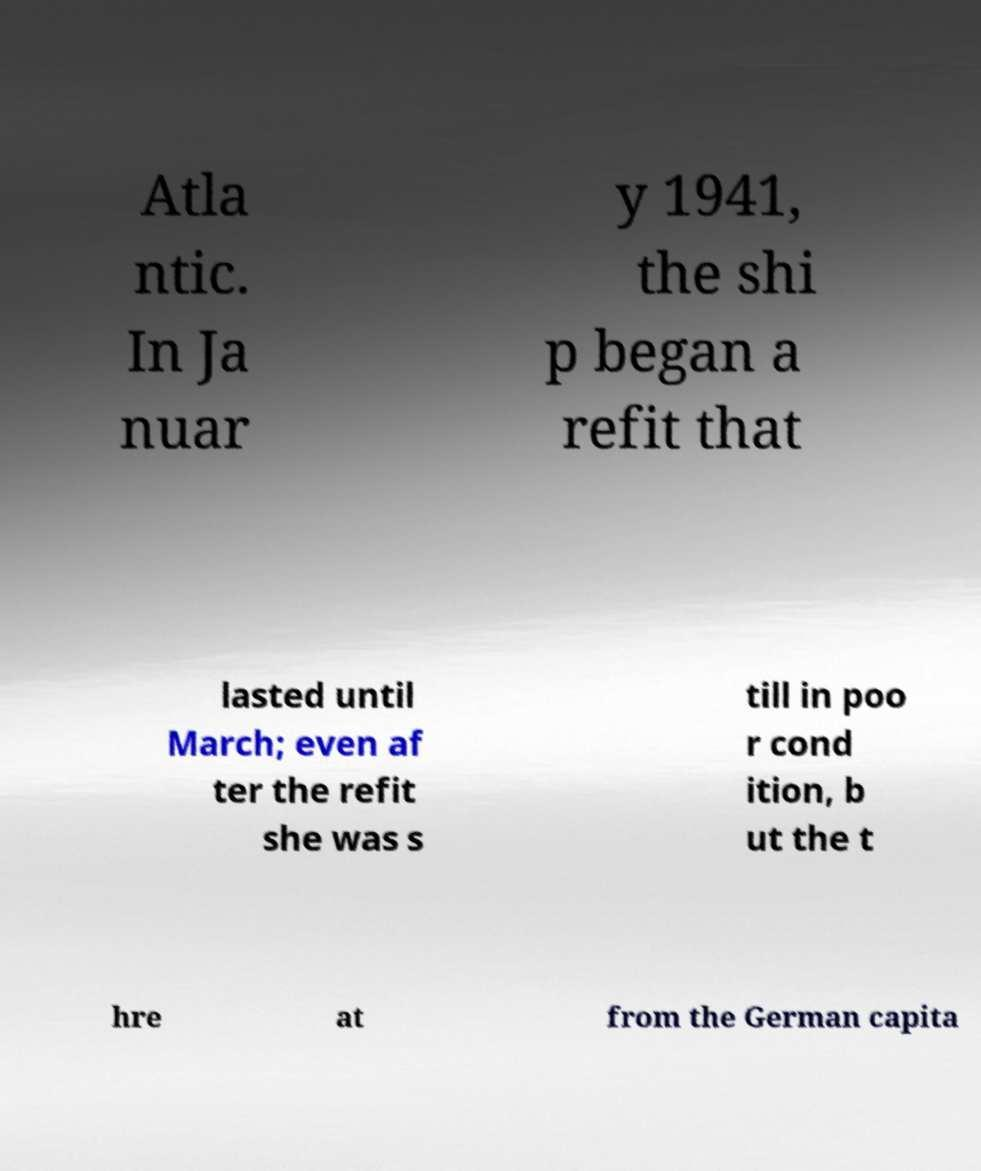There's text embedded in this image that I need extracted. Can you transcribe it verbatim? Atla ntic. In Ja nuar y 1941, the shi p began a refit that lasted until March; even af ter the refit she was s till in poo r cond ition, b ut the t hre at from the German capita 